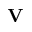Convert formula to latex. <formula><loc_0><loc_0><loc_500><loc_500>{ V }</formula> 